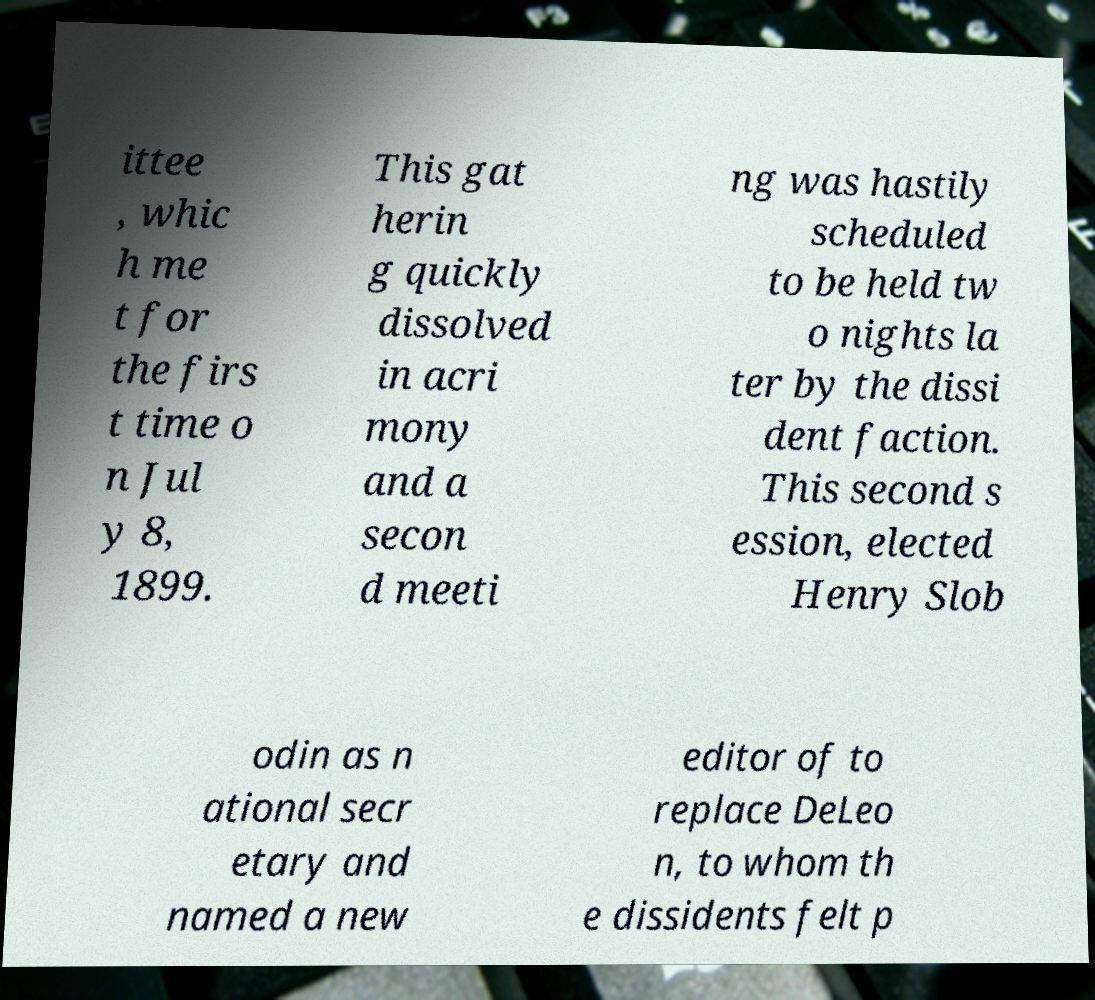Could you assist in decoding the text presented in this image and type it out clearly? ittee , whic h me t for the firs t time o n Jul y 8, 1899. This gat herin g quickly dissolved in acri mony and a secon d meeti ng was hastily scheduled to be held tw o nights la ter by the dissi dent faction. This second s ession, elected Henry Slob odin as n ational secr etary and named a new editor of to replace DeLeo n, to whom th e dissidents felt p 